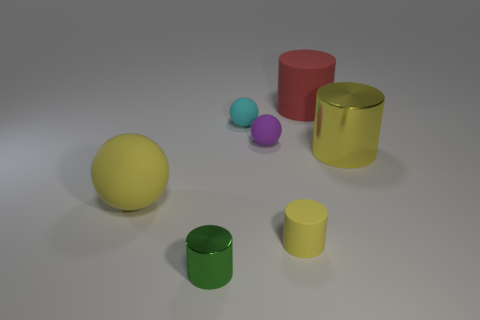Subtract all red rubber cylinders. How many cylinders are left? 3 Add 1 tiny green metallic blocks. How many objects exist? 8 Subtract all yellow balls. How many balls are left? 2 Subtract 1 balls. How many balls are left? 2 Subtract all cylinders. How many objects are left? 3 Add 3 metal cylinders. How many metal cylinders are left? 5 Add 6 large rubber things. How many large rubber things exist? 8 Subtract 0 cyan blocks. How many objects are left? 7 Subtract all green balls. Subtract all blue cubes. How many balls are left? 3 Subtract all yellow balls. How many cyan cylinders are left? 0 